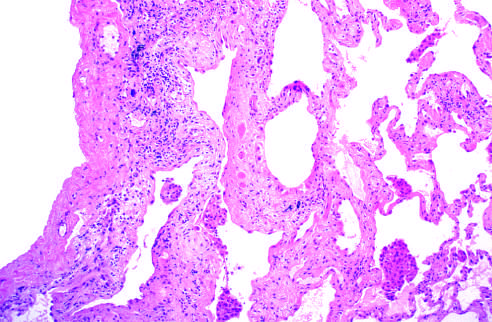what is more pronounced in the subpleural region?
Answer the question using a single word or phrase. The fibrosis 